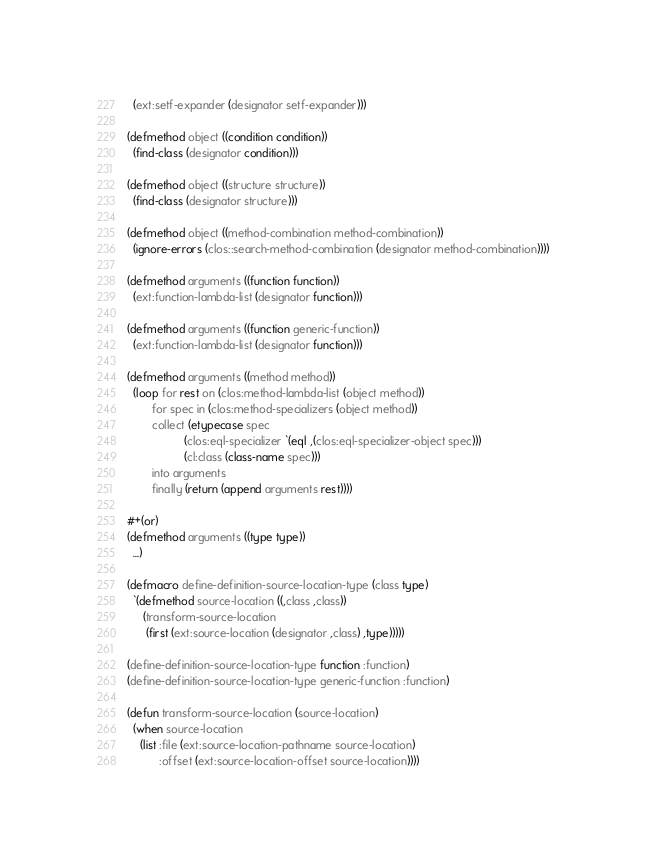<code> <loc_0><loc_0><loc_500><loc_500><_Lisp_>  (ext:setf-expander (designator setf-expander)))

(defmethod object ((condition condition))
  (find-class (designator condition)))

(defmethod object ((structure structure))
  (find-class (designator structure)))

(defmethod object ((method-combination method-combination))
  (ignore-errors (clos::search-method-combination (designator method-combination))))

(defmethod arguments ((function function))
  (ext:function-lambda-list (designator function)))

(defmethod arguments ((function generic-function))
  (ext:function-lambda-list (designator function)))

(defmethod arguments ((method method))
  (loop for rest on (clos:method-lambda-list (object method))
        for spec in (clos:method-specializers (object method))
        collect (etypecase spec
                  (clos:eql-specializer `(eql ,(clos:eql-specializer-object spec)))
                  (cl:class (class-name spec)))
        into arguments
        finally (return (append arguments rest))))

#+(or)
(defmethod arguments ((type type))
  ...)

(defmacro define-definition-source-location-type (class type)
  `(defmethod source-location ((,class ,class))
     (transform-source-location
      (first (ext:source-location (designator ,class) ,type)))))

(define-definition-source-location-type function :function)
(define-definition-source-location-type generic-function :function)

(defun transform-source-location (source-location)
  (when source-location
    (list :file (ext:source-location-pathname source-location)
          :offset (ext:source-location-offset source-location))))
</code> 